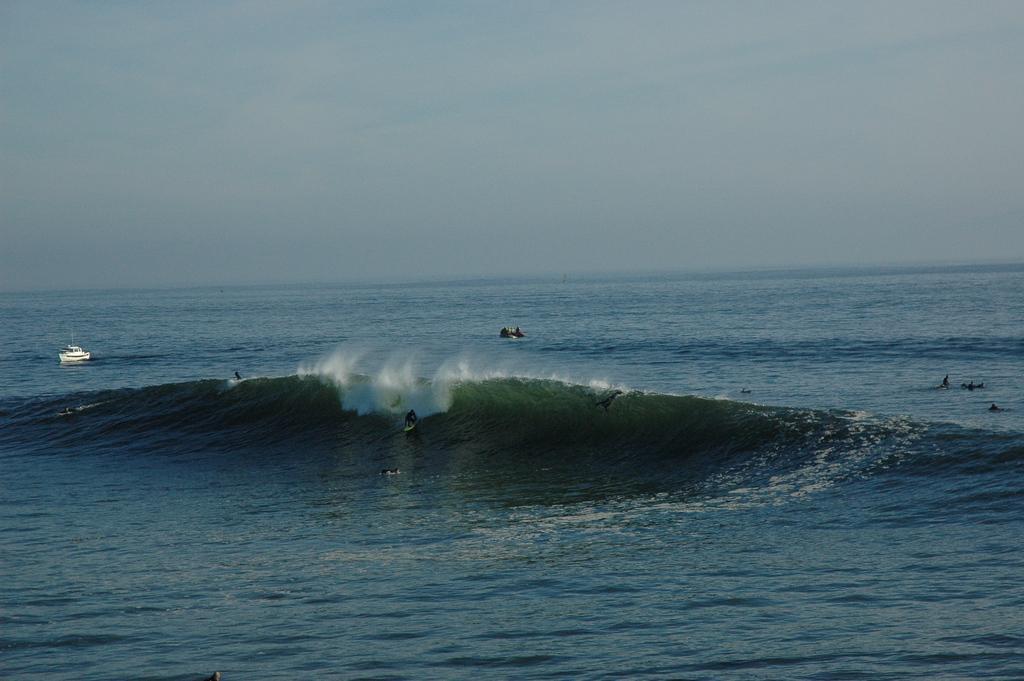Describe this image in one or two sentences. In the image there is water with waves. There are few people surfing on the waves. And also there is a ship on the water. At the top of the image there is sky. 